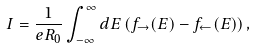Convert formula to latex. <formula><loc_0><loc_0><loc_500><loc_500>I = \frac { 1 } { e R _ { 0 } } \int _ { - \infty } ^ { \infty } d E \left ( f _ { \rightarrow } ( E ) - f _ { \leftarrow } ( E ) \right ) ,</formula> 